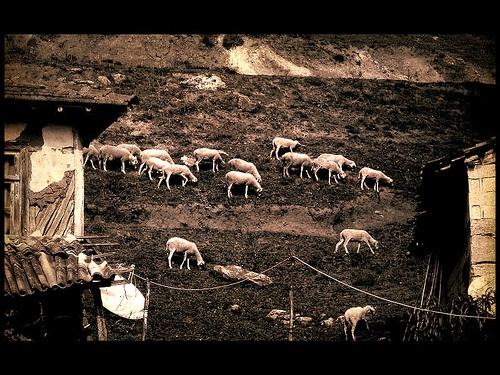Describe the objects in this image and their specific colors. I can see sheep in black, ivory, tan, and gray tones, sheep in black, ivory, and tan tones, sheep in black, gray, and tan tones, sheep in black, tan, and ivory tones, and sheep in black, ivory, gray, and tan tones in this image. 